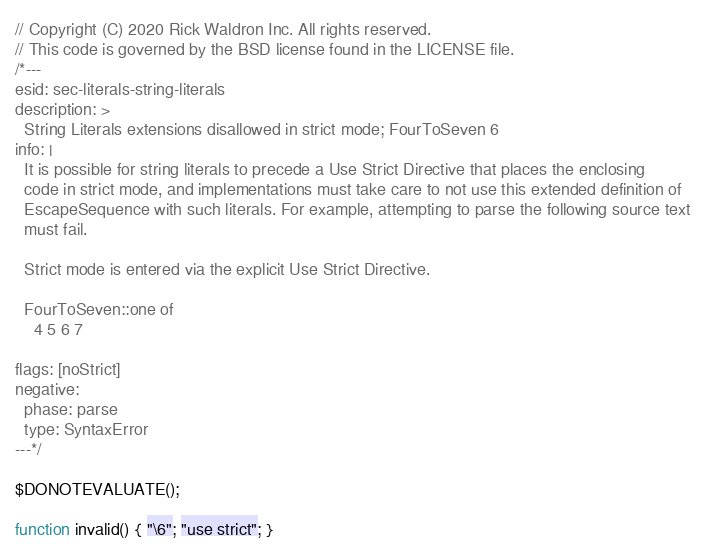<code> <loc_0><loc_0><loc_500><loc_500><_JavaScript_>// Copyright (C) 2020 Rick Waldron Inc. All rights reserved.
// This code is governed by the BSD license found in the LICENSE file.
/*---
esid: sec-literals-string-literals
description: >
  String Literals extensions disallowed in strict mode; FourToSeven 6
info: |
  It is possible for string literals to precede a Use Strict Directive that places the enclosing
  code in strict mode, and implementations must take care to not use this extended definition of
  EscapeSequence with such literals. For example, attempting to parse the following source text
  must fail.

  Strict mode is entered via the explicit Use Strict Directive.

  FourToSeven::one of
    4 5 6 7

flags: [noStrict]
negative:
  phase: parse
  type: SyntaxError
---*/

$DONOTEVALUATE();

function invalid() { "\6"; "use strict"; }
</code> 